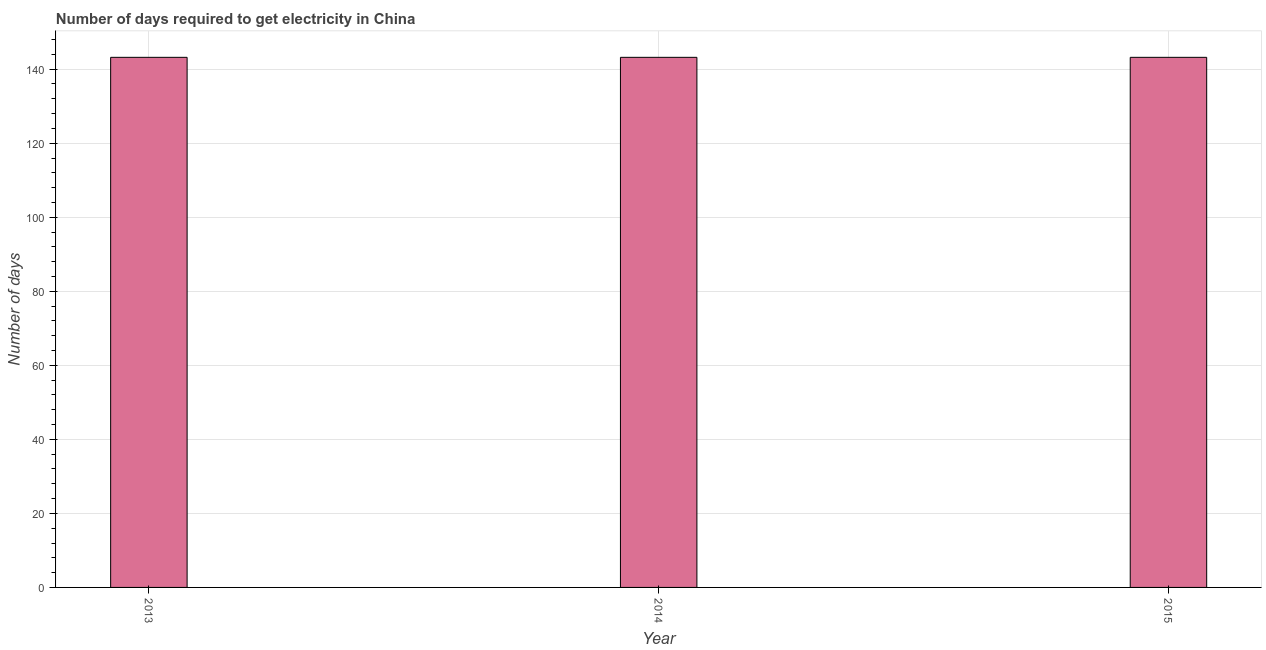Does the graph contain any zero values?
Offer a very short reply. No. Does the graph contain grids?
Your response must be concise. Yes. What is the title of the graph?
Make the answer very short. Number of days required to get electricity in China. What is the label or title of the Y-axis?
Ensure brevity in your answer.  Number of days. What is the time to get electricity in 2015?
Provide a short and direct response. 143.2. Across all years, what is the maximum time to get electricity?
Your answer should be very brief. 143.2. Across all years, what is the minimum time to get electricity?
Provide a short and direct response. 143.2. In which year was the time to get electricity maximum?
Make the answer very short. 2013. What is the sum of the time to get electricity?
Your answer should be compact. 429.6. What is the average time to get electricity per year?
Offer a terse response. 143.2. What is the median time to get electricity?
Your answer should be compact. 143.2. In how many years, is the time to get electricity greater than 116 ?
Make the answer very short. 3. What is the difference between the highest and the second highest time to get electricity?
Offer a very short reply. 0. Is the sum of the time to get electricity in 2013 and 2014 greater than the maximum time to get electricity across all years?
Your response must be concise. Yes. What is the difference between the highest and the lowest time to get electricity?
Your answer should be very brief. 0. In how many years, is the time to get electricity greater than the average time to get electricity taken over all years?
Provide a short and direct response. 0. How many years are there in the graph?
Your response must be concise. 3. What is the difference between two consecutive major ticks on the Y-axis?
Keep it short and to the point. 20. Are the values on the major ticks of Y-axis written in scientific E-notation?
Offer a terse response. No. What is the Number of days in 2013?
Give a very brief answer. 143.2. What is the Number of days in 2014?
Provide a short and direct response. 143.2. What is the Number of days in 2015?
Provide a succinct answer. 143.2. What is the difference between the Number of days in 2013 and 2014?
Give a very brief answer. 0. What is the ratio of the Number of days in 2013 to that in 2014?
Provide a succinct answer. 1. 